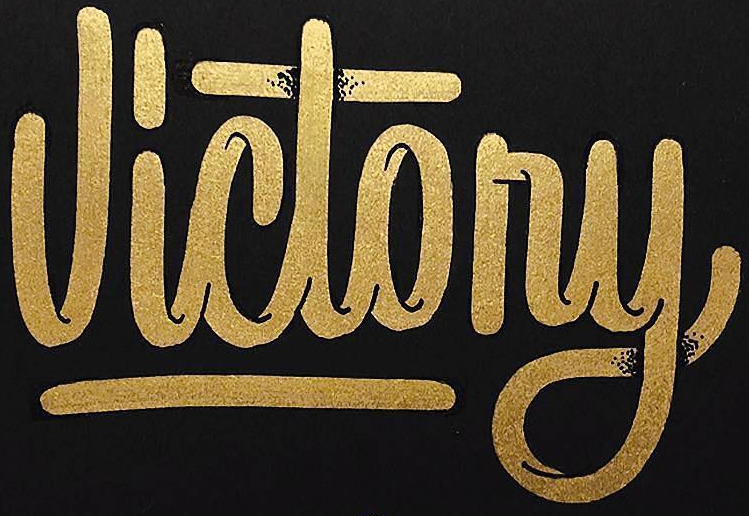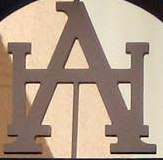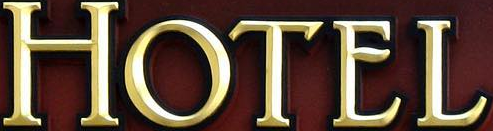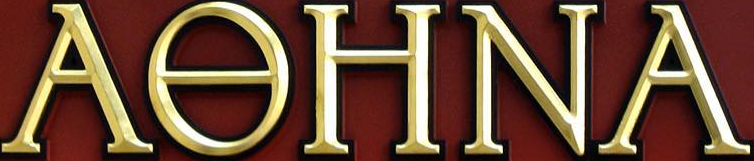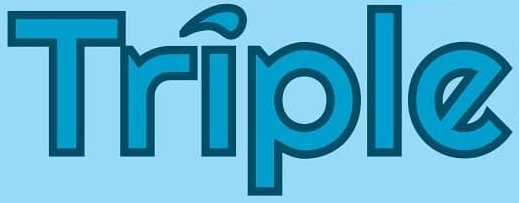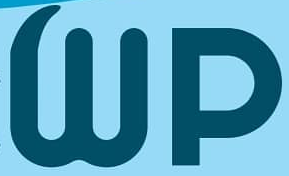Identify the words shown in these images in order, separated by a semicolon. Victony; HA; HOTEL; AƟHNA; Triple; Wp 